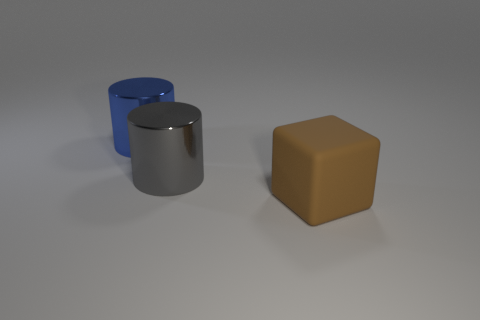Add 2 large gray shiny objects. How many objects exist? 5 Subtract all cylinders. How many objects are left? 1 Subtract all metallic objects. Subtract all big brown things. How many objects are left? 0 Add 3 blue metallic cylinders. How many blue metallic cylinders are left? 4 Add 3 big green metallic cubes. How many big green metallic cubes exist? 3 Subtract 0 green balls. How many objects are left? 3 